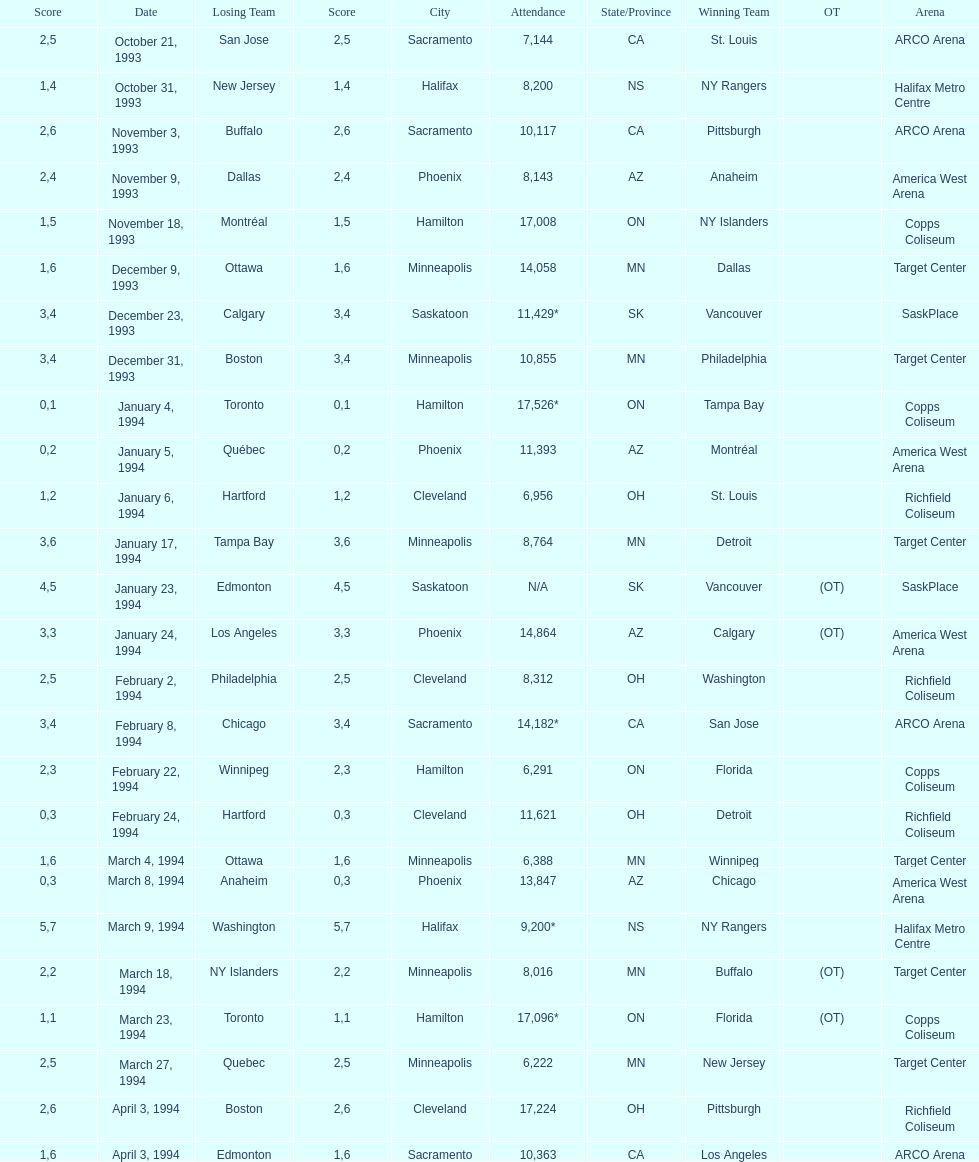Could you parse the entire table? {'header': ['Score', 'Date', 'Losing Team', 'Score', 'City', 'Attendance', 'State/Province', 'Winning Team', 'OT', 'Arena'], 'rows': [['2', 'October 21, 1993', 'San Jose', '5', 'Sacramento', '7,144', 'CA', 'St. Louis', '', 'ARCO Arena'], ['1', 'October 31, 1993', 'New Jersey', '4', 'Halifax', '8,200', 'NS', 'NY Rangers', '', 'Halifax Metro Centre'], ['2', 'November 3, 1993', 'Buffalo', '6', 'Sacramento', '10,117', 'CA', 'Pittsburgh', '', 'ARCO Arena'], ['2', 'November 9, 1993', 'Dallas', '4', 'Phoenix', '8,143', 'AZ', 'Anaheim', '', 'America West Arena'], ['1', 'November 18, 1993', 'Montréal', '5', 'Hamilton', '17,008', 'ON', 'NY Islanders', '', 'Copps Coliseum'], ['1', 'December 9, 1993', 'Ottawa', '6', 'Minneapolis', '14,058', 'MN', 'Dallas', '', 'Target Center'], ['3', 'December 23, 1993', 'Calgary', '4', 'Saskatoon', '11,429*', 'SK', 'Vancouver', '', 'SaskPlace'], ['3', 'December 31, 1993', 'Boston', '4', 'Minneapolis', '10,855', 'MN', 'Philadelphia', '', 'Target Center'], ['0', 'January 4, 1994', 'Toronto', '1', 'Hamilton', '17,526*', 'ON', 'Tampa Bay', '', 'Copps Coliseum'], ['0', 'January 5, 1994', 'Québec', '2', 'Phoenix', '11,393', 'AZ', 'Montréal', '', 'America West Arena'], ['1', 'January 6, 1994', 'Hartford', '2', 'Cleveland', '6,956', 'OH', 'St. Louis', '', 'Richfield Coliseum'], ['3', 'January 17, 1994', 'Tampa Bay', '6', 'Minneapolis', '8,764', 'MN', 'Detroit', '', 'Target Center'], ['4', 'January 23, 1994', 'Edmonton', '5', 'Saskatoon', 'N/A', 'SK', 'Vancouver', '(OT)', 'SaskPlace'], ['3', 'January 24, 1994', 'Los Angeles', '3', 'Phoenix', '14,864', 'AZ', 'Calgary', '(OT)', 'America West Arena'], ['2', 'February 2, 1994', 'Philadelphia', '5', 'Cleveland', '8,312', 'OH', 'Washington', '', 'Richfield Coliseum'], ['3', 'February 8, 1994', 'Chicago', '4', 'Sacramento', '14,182*', 'CA', 'San Jose', '', 'ARCO Arena'], ['2', 'February 22, 1994', 'Winnipeg', '3', 'Hamilton', '6,291', 'ON', 'Florida', '', 'Copps Coliseum'], ['0', 'February 24, 1994', 'Hartford', '3', 'Cleveland', '11,621', 'OH', 'Detroit', '', 'Richfield Coliseum'], ['1', 'March 4, 1994', 'Ottawa', '6', 'Minneapolis', '6,388', 'MN', 'Winnipeg', '', 'Target Center'], ['0', 'March 8, 1994', 'Anaheim', '3', 'Phoenix', '13,847', 'AZ', 'Chicago', '', 'America West Arena'], ['5', 'March 9, 1994', 'Washington', '7', 'Halifax', '9,200*', 'NS', 'NY Rangers', '', 'Halifax Metro Centre'], ['2', 'March 18, 1994', 'NY Islanders', '2', 'Minneapolis', '8,016', 'MN', 'Buffalo', '(OT)', 'Target Center'], ['1', 'March 23, 1994', 'Toronto', '1', 'Hamilton', '17,096*', 'ON', 'Florida', '(OT)', 'Copps Coliseum'], ['2', 'March 27, 1994', 'Quebec', '5', 'Minneapolis', '6,222', 'MN', 'New Jersey', '', 'Target Center'], ['2', 'April 3, 1994', 'Boston', '6', 'Cleveland', '17,224', 'OH', 'Pittsburgh', '', 'Richfield Coliseum'], ['1', 'April 3, 1994', 'Edmonton', '6', 'Sacramento', '10,363', 'CA', 'Los Angeles', '', 'ARCO Arena']]} Did dallas or ottawa win the december 9, 1993 game? Dallas. 